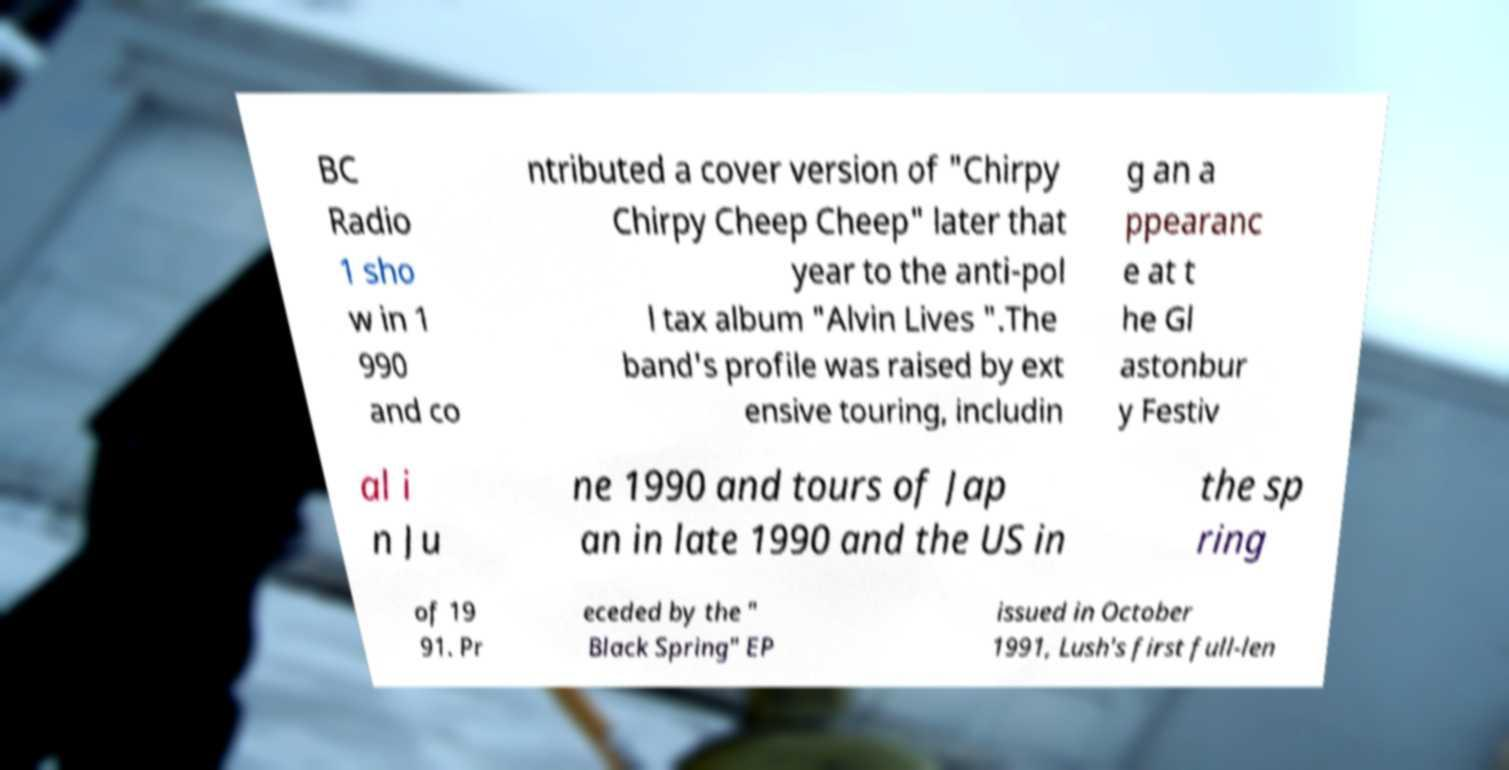For documentation purposes, I need the text within this image transcribed. Could you provide that? BC Radio 1 sho w in 1 990 and co ntributed a cover version of "Chirpy Chirpy Cheep Cheep" later that year to the anti-pol l tax album "Alvin Lives ".The band's profile was raised by ext ensive touring, includin g an a ppearanc e at t he Gl astonbur y Festiv al i n Ju ne 1990 and tours of Jap an in late 1990 and the US in the sp ring of 19 91. Pr eceded by the " Black Spring" EP issued in October 1991, Lush's first full-len 